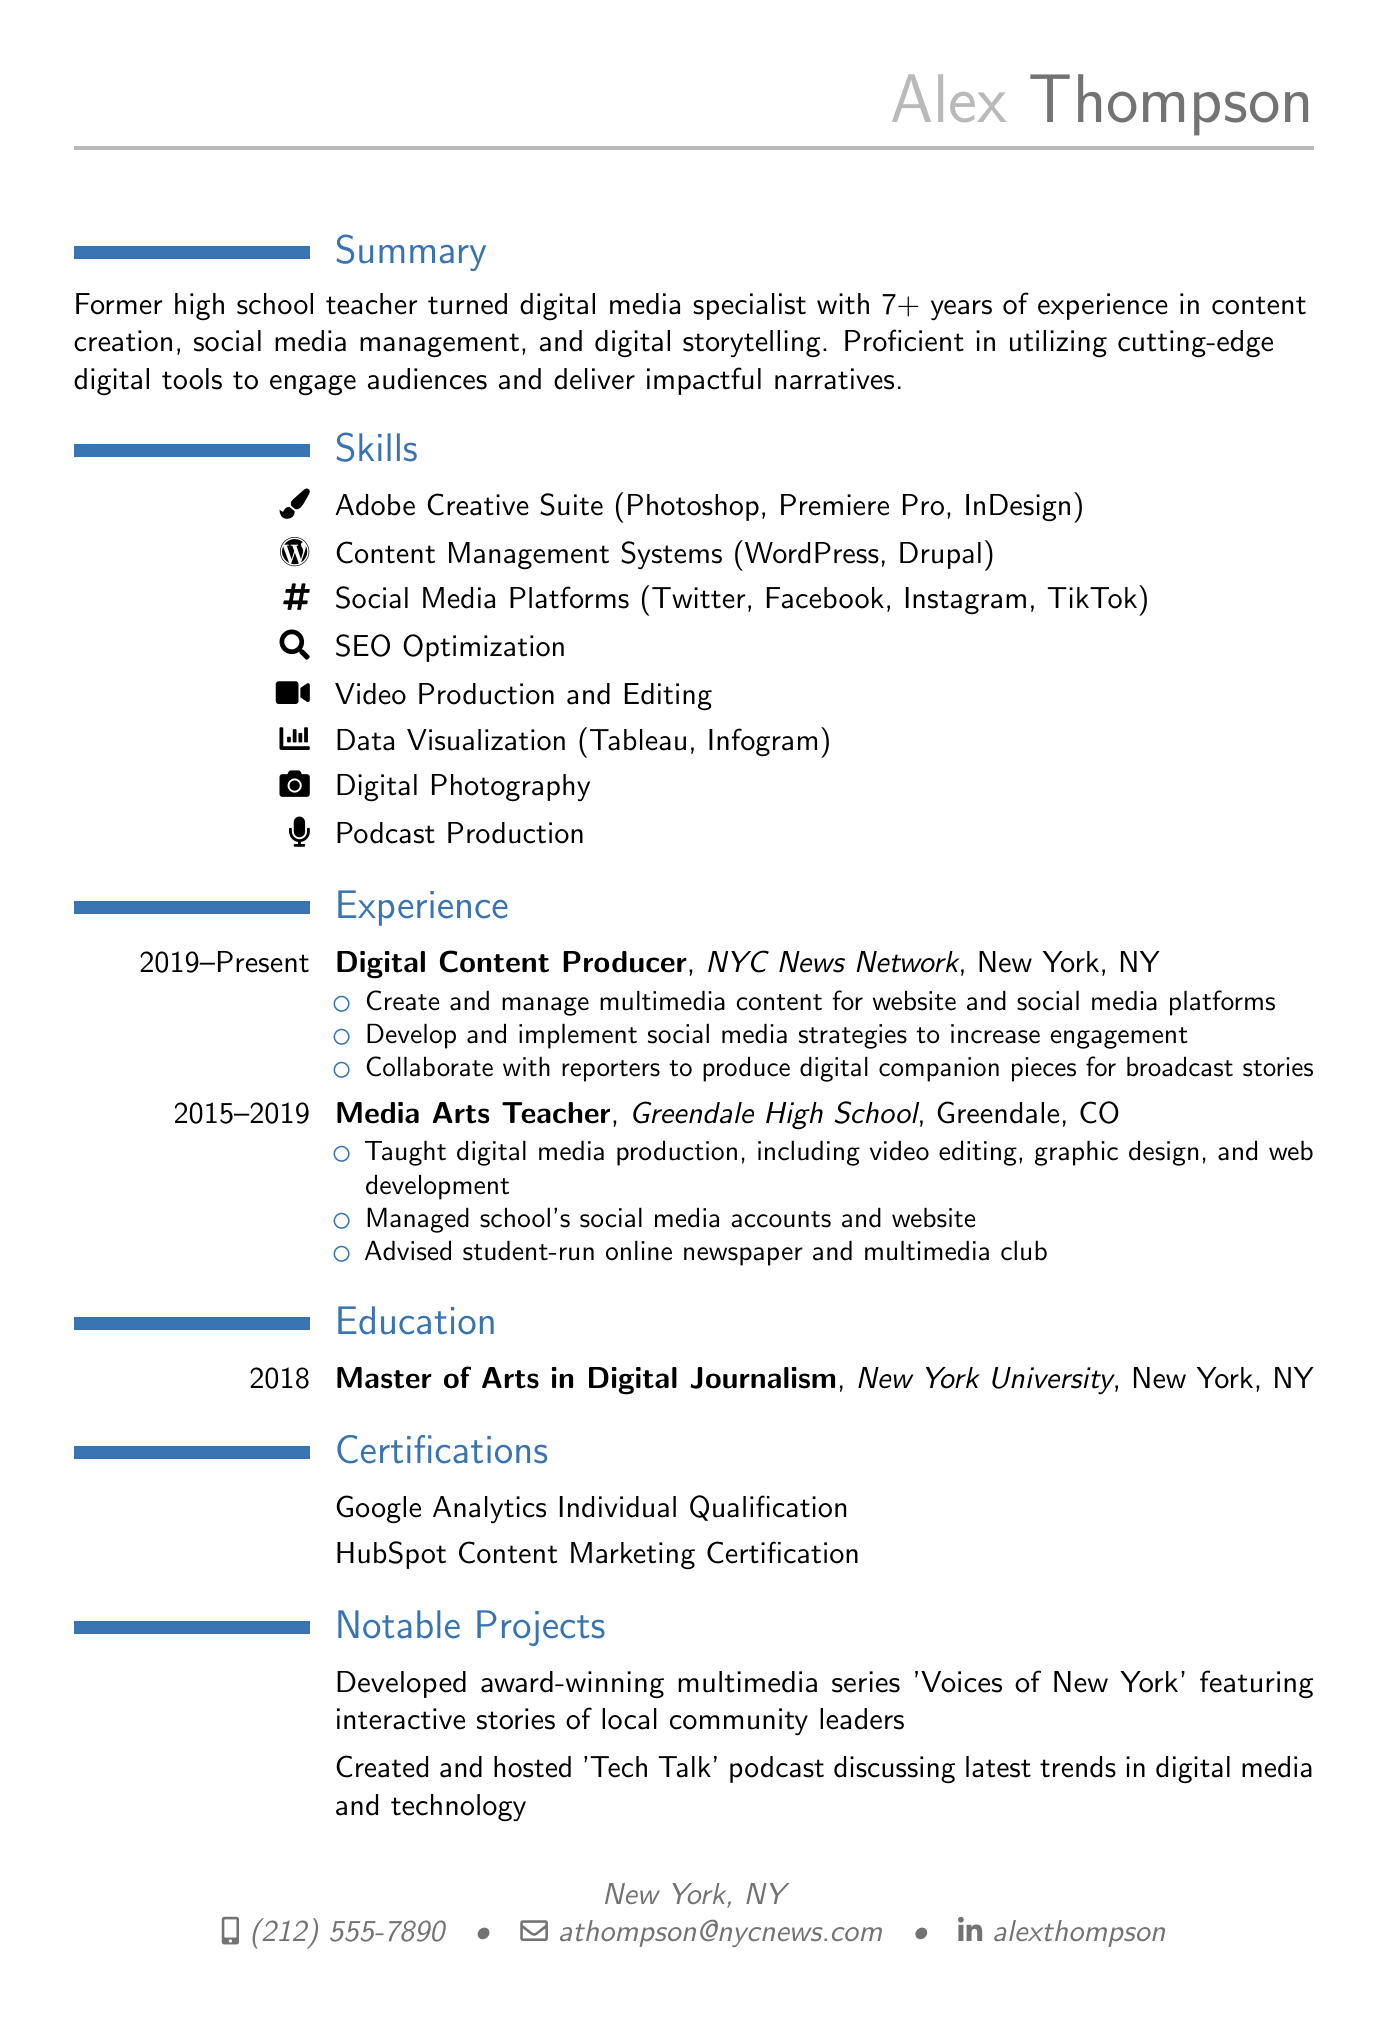What is the name of the person? The name of the person listed in the document is found in the personal information section.
Answer: Alex Thompson What is Alex's email address? The email address provided is part of the personal information section of the CV.
Answer: athompson@nycnews.com In what year did Alex complete their Master's degree? The year of graduation appears in the education section of the document.
Answer: 2018 What is the current job title of Alex? The current job title can be found in the experience section under the most recent position.
Answer: Digital Content Producer How many years of experience does Alex have in digital media? The amount of experience is quantified in the summary section of the CV.
Answer: 7+ What type of certification does Alex hold related to analytics? The certifications section mentions specific qualifications, including analytics-related certifications.
Answer: Google Analytics Individual Qualification Which school did Alex teach at? The name of the school is listed in the experience section under the teaching role.
Answer: Greendale High School What notable project did Alex create related to community leaders? Notable projects are listed specifically in their own section, describing achievements.
Answer: 'Voices of New York' What social media platforms is Alex experienced with? A list of social media platforms is provided in the skills section of the CV.
Answer: Twitter, Facebook, Instagram, TikTok 